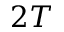<formula> <loc_0><loc_0><loc_500><loc_500>2 T</formula> 